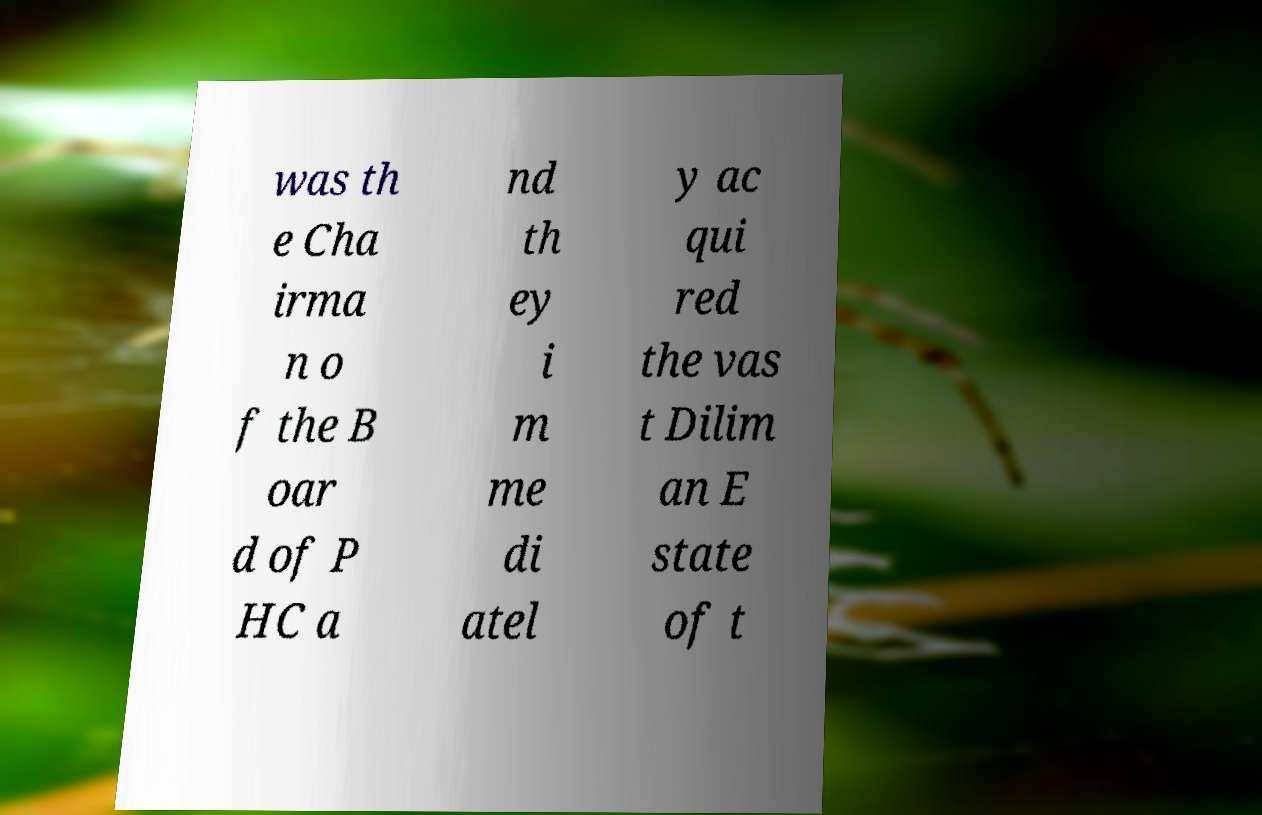Please read and relay the text visible in this image. What does it say? was th e Cha irma n o f the B oar d of P HC a nd th ey i m me di atel y ac qui red the vas t Dilim an E state of t 